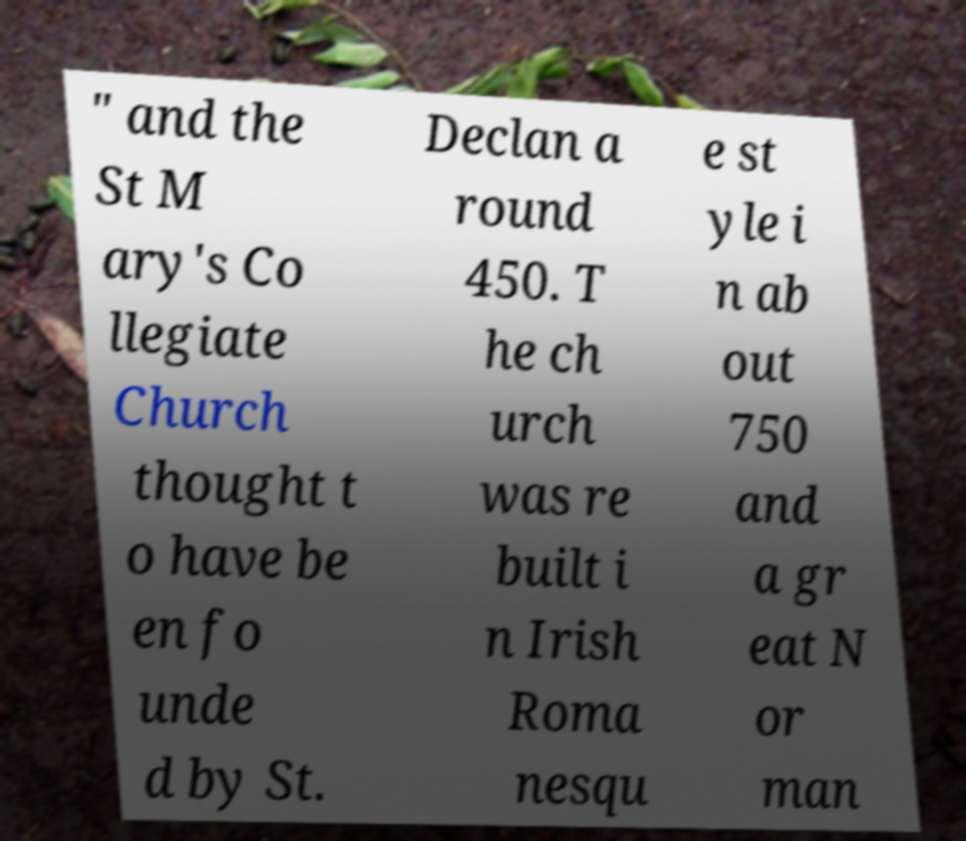Please read and relay the text visible in this image. What does it say? " and the St M ary's Co llegiate Church thought t o have be en fo unde d by St. Declan a round 450. T he ch urch was re built i n Irish Roma nesqu e st yle i n ab out 750 and a gr eat N or man 